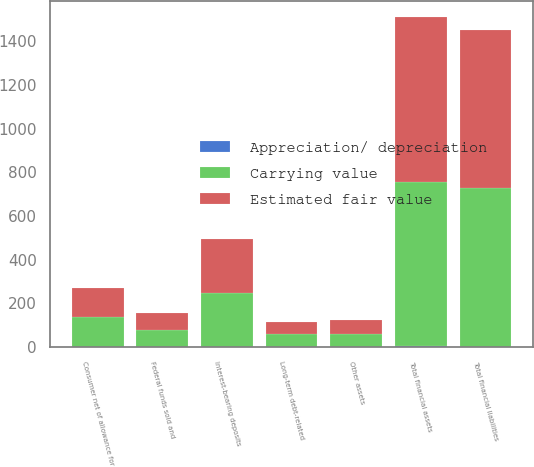<chart> <loc_0><loc_0><loc_500><loc_500><stacked_bar_chart><ecel><fcel>Federal funds sold and<fcel>Consumer net of allowance for<fcel>Other assets<fcel>Total financial assets<fcel>Interest-bearing deposits<fcel>Long-term debt-related<fcel>Total financial liabilities<nl><fcel>Estimated fair value<fcel>76.9<fcel>134.2<fcel>61<fcel>750.7<fcel>247<fcel>54.8<fcel>723.6<nl><fcel>Carrying value<fcel>77.2<fcel>135.4<fcel>61.5<fcel>754<fcel>247.1<fcel>57<fcel>726<nl><fcel>Appreciation/ depreciation<fcel>0.3<fcel>1.2<fcel>0.5<fcel>3.3<fcel>0.1<fcel>2.2<fcel>2.4<nl></chart> 